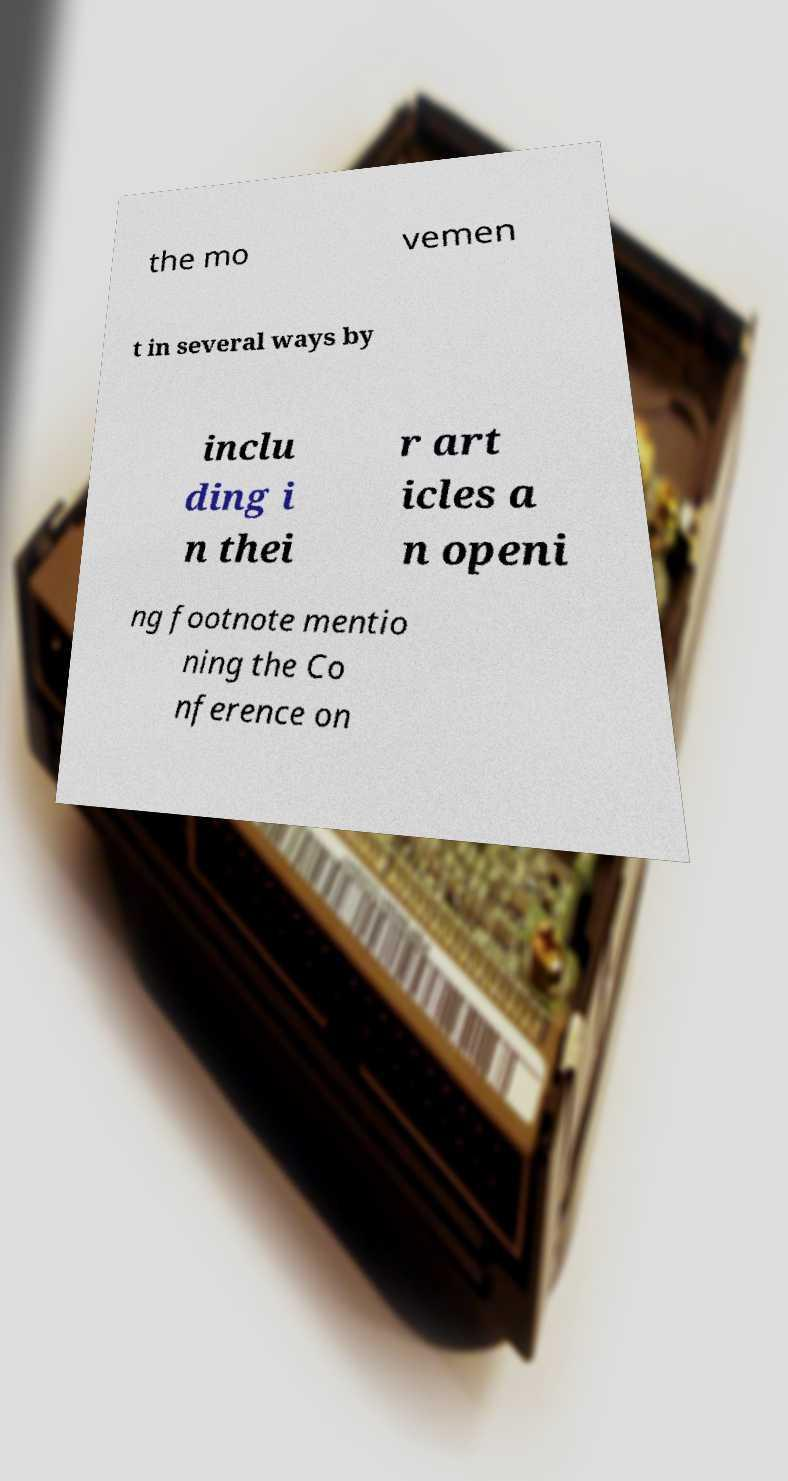Can you accurately transcribe the text from the provided image for me? the mo vemen t in several ways by inclu ding i n thei r art icles a n openi ng footnote mentio ning the Co nference on 